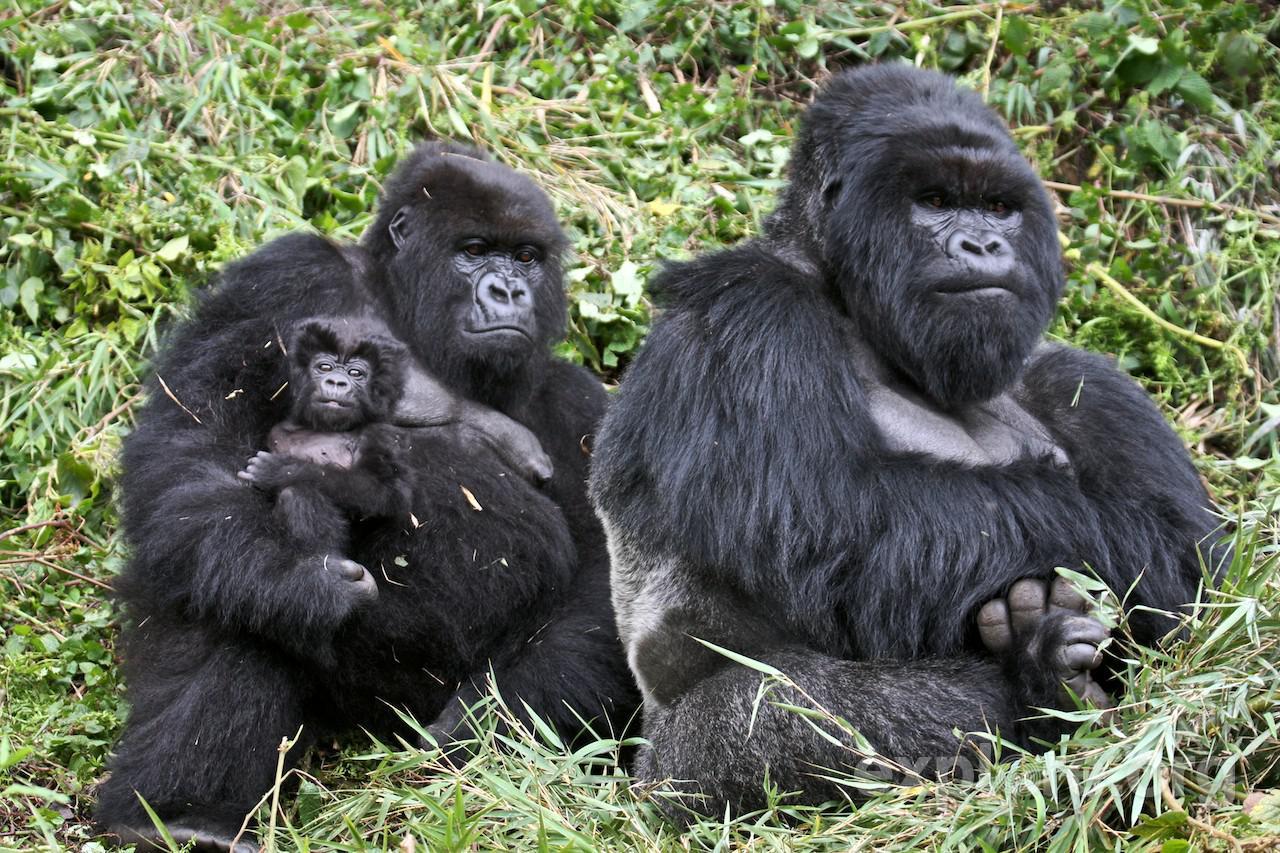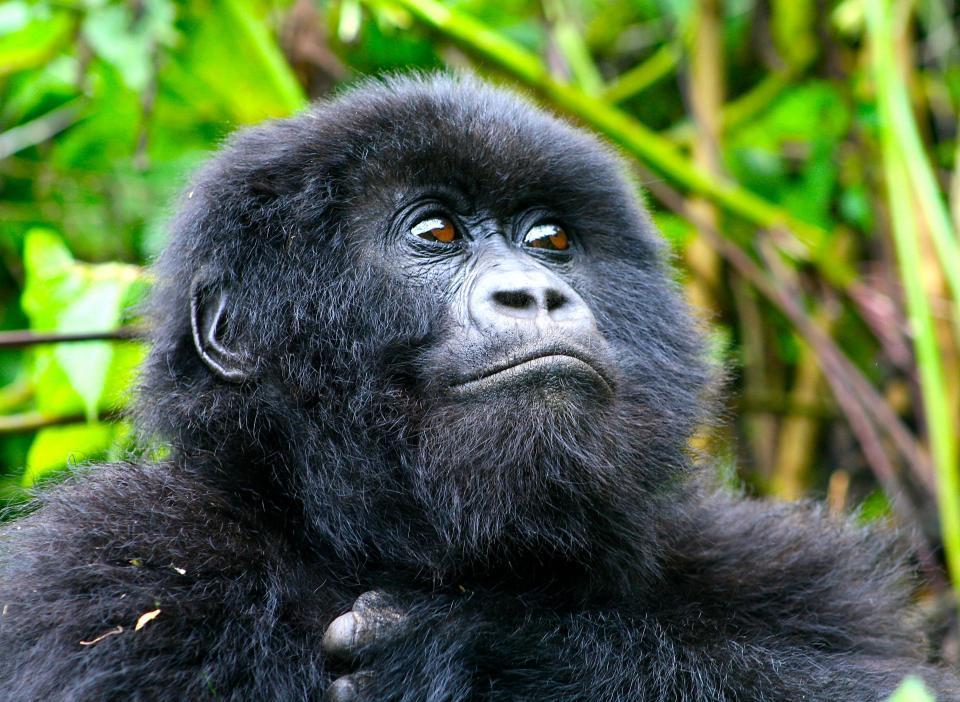The first image is the image on the left, the second image is the image on the right. Given the left and right images, does the statement "None of the apes are carrying a baby." hold true? Answer yes or no. No. The first image is the image on the left, the second image is the image on the right. Assess this claim about the two images: "An image contains a single gorilla with brown eyes and soft-looking hair.". Correct or not? Answer yes or no. Yes. 